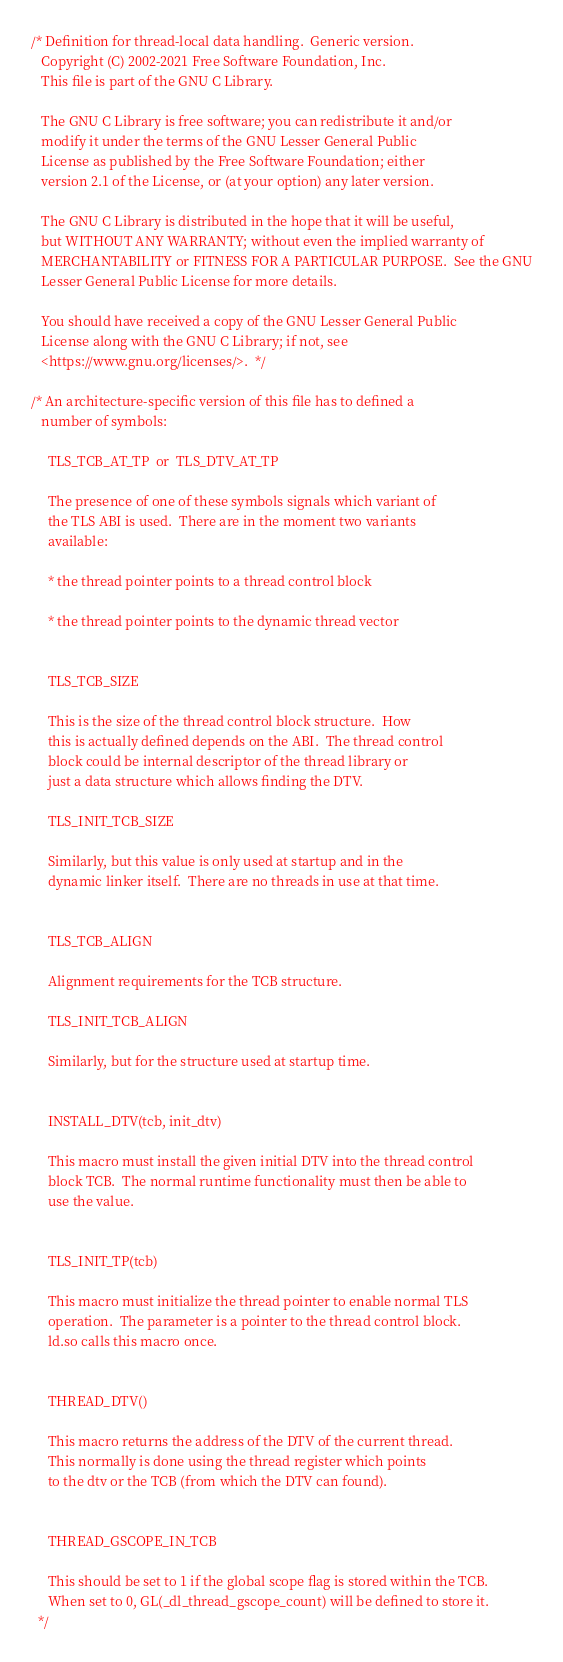Convert code to text. <code><loc_0><loc_0><loc_500><loc_500><_C_>/* Definition for thread-local data handling.  Generic version.
   Copyright (C) 2002-2021 Free Software Foundation, Inc.
   This file is part of the GNU C Library.

   The GNU C Library is free software; you can redistribute it and/or
   modify it under the terms of the GNU Lesser General Public
   License as published by the Free Software Foundation; either
   version 2.1 of the License, or (at your option) any later version.

   The GNU C Library is distributed in the hope that it will be useful,
   but WITHOUT ANY WARRANTY; without even the implied warranty of
   MERCHANTABILITY or FITNESS FOR A PARTICULAR PURPOSE.  See the GNU
   Lesser General Public License for more details.

   You should have received a copy of the GNU Lesser General Public
   License along with the GNU C Library; if not, see
   <https://www.gnu.org/licenses/>.  */

/* An architecture-specific version of this file has to defined a
   number of symbols:

     TLS_TCB_AT_TP  or  TLS_DTV_AT_TP

     The presence of one of these symbols signals which variant of
     the TLS ABI is used.  There are in the moment two variants
     available:

     * the thread pointer points to a thread control block

     * the thread pointer points to the dynamic thread vector


     TLS_TCB_SIZE

     This is the size of the thread control block structure.  How
     this is actually defined depends on the ABI.  The thread control
     block could be internal descriptor of the thread library or
     just a data structure which allows finding the DTV.

     TLS_INIT_TCB_SIZE

     Similarly, but this value is only used at startup and in the
     dynamic linker itself.  There are no threads in use at that time.


     TLS_TCB_ALIGN

     Alignment requirements for the TCB structure.

     TLS_INIT_TCB_ALIGN

     Similarly, but for the structure used at startup time.


     INSTALL_DTV(tcb, init_dtv)

     This macro must install the given initial DTV into the thread control
     block TCB.  The normal runtime functionality must then be able to
     use the value.


     TLS_INIT_TP(tcb)

     This macro must initialize the thread pointer to enable normal TLS
     operation.  The parameter is a pointer to the thread control block.
     ld.so calls this macro once.


     THREAD_DTV()

     This macro returns the address of the DTV of the current thread.
     This normally is done using the thread register which points
     to the dtv or the TCB (from which the DTV can found).


     THREAD_GSCOPE_IN_TCB

     This should be set to 1 if the global scope flag is stored within the TCB.
     When set to 0, GL(_dl_thread_gscope_count) will be defined to store it.
  */
</code> 